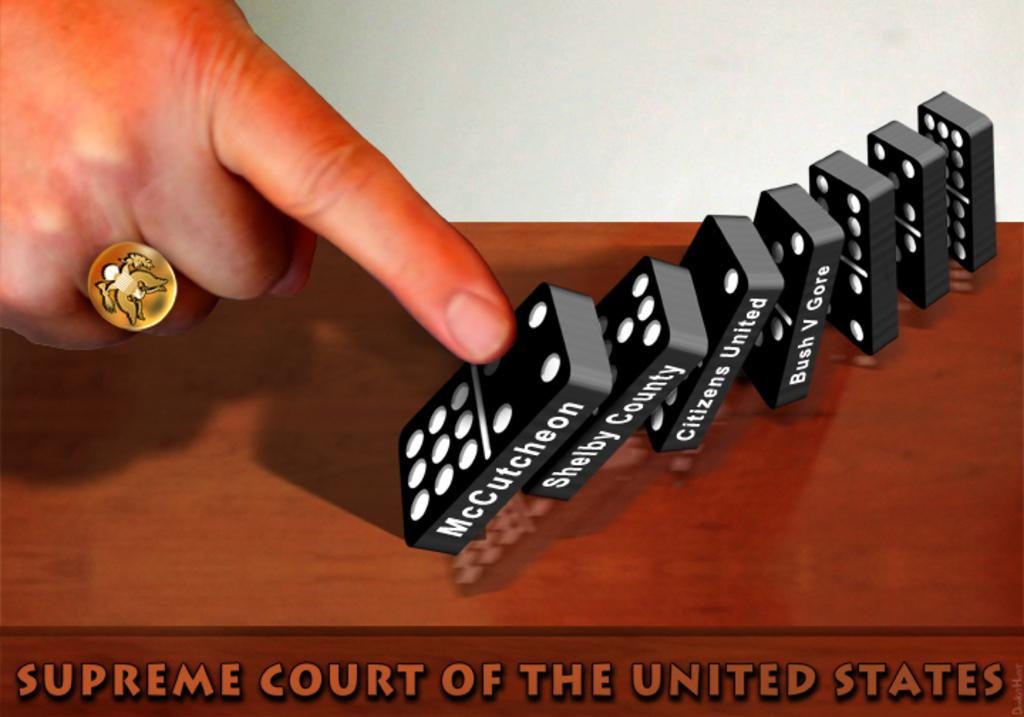Provide a one-sentence caption for the provided image. A political statement using dominoes to show the role of the Supreme Court of The United States. 